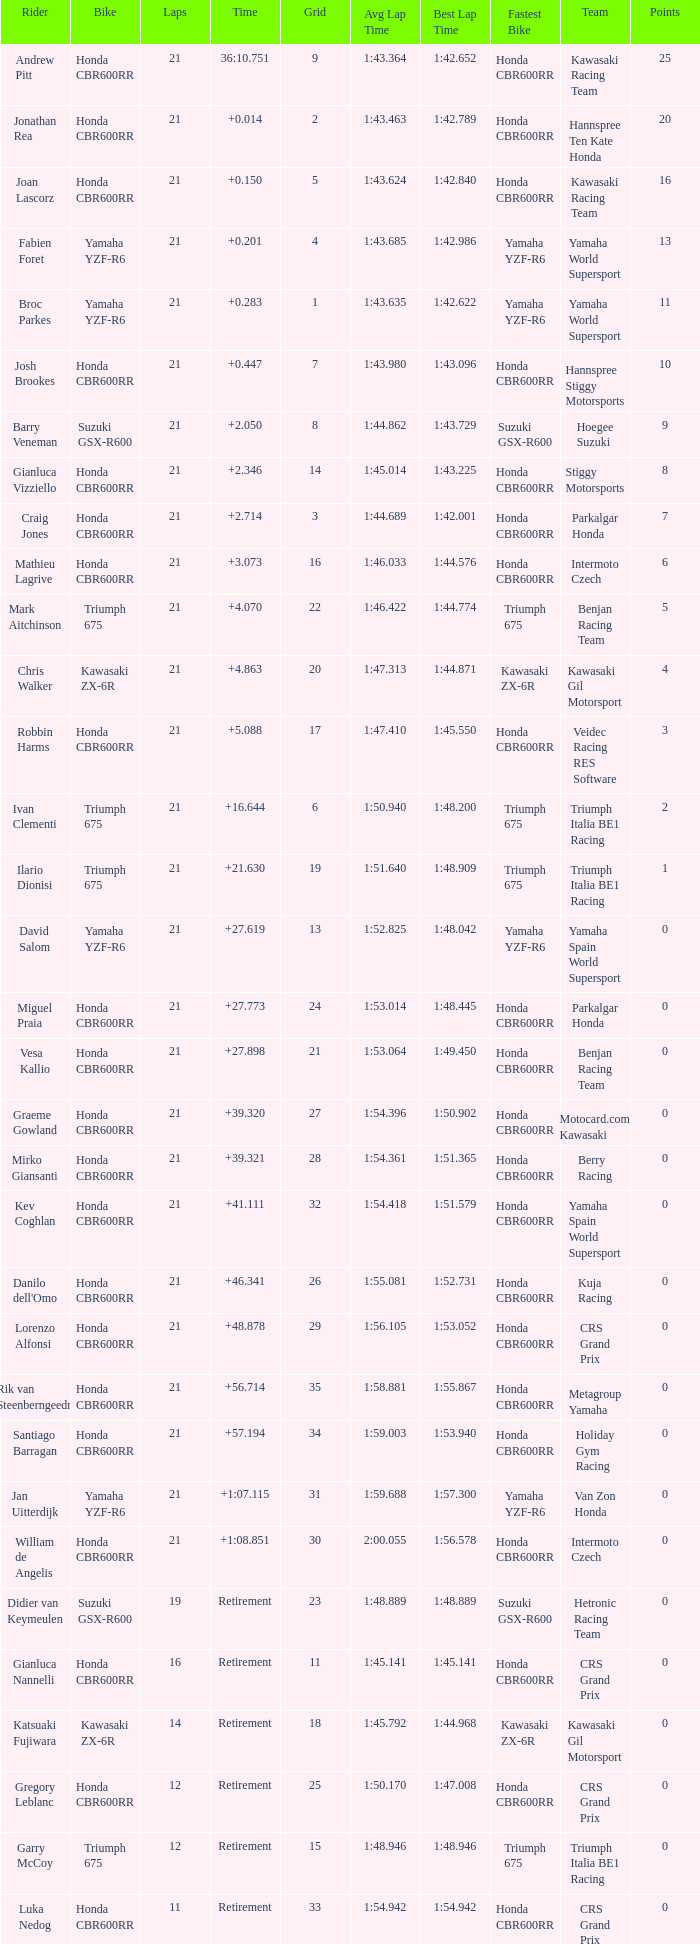What is the most number of laps run by Ilario Dionisi? 21.0. 